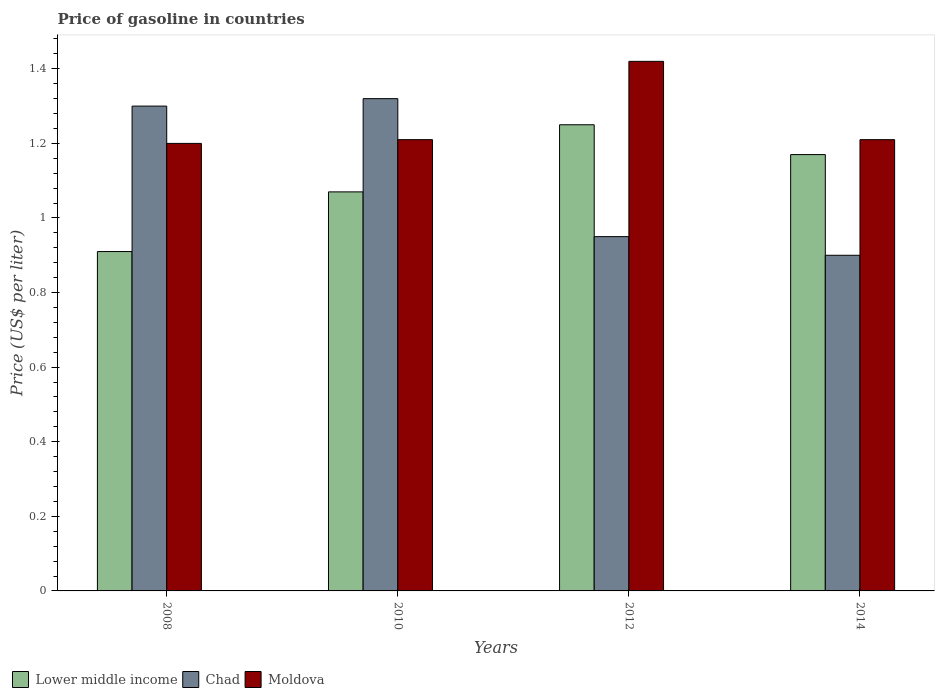How many groups of bars are there?
Provide a succinct answer. 4. How many bars are there on the 1st tick from the right?
Ensure brevity in your answer.  3. What is the price of gasoline in Chad in 2010?
Make the answer very short. 1.32. Across all years, what is the maximum price of gasoline in Lower middle income?
Your answer should be very brief. 1.25. Across all years, what is the minimum price of gasoline in Lower middle income?
Give a very brief answer. 0.91. What is the total price of gasoline in Lower middle income in the graph?
Keep it short and to the point. 4.4. What is the difference between the price of gasoline in Chad in 2010 and that in 2012?
Your answer should be compact. 0.37. What is the difference between the price of gasoline in Lower middle income in 2008 and the price of gasoline in Moldova in 2012?
Your answer should be compact. -0.51. What is the average price of gasoline in Lower middle income per year?
Give a very brief answer. 1.1. In the year 2008, what is the difference between the price of gasoline in Moldova and price of gasoline in Lower middle income?
Your answer should be compact. 0.29. In how many years, is the price of gasoline in Moldova greater than 0.12 US$?
Offer a very short reply. 4. What is the ratio of the price of gasoline in Moldova in 2008 to that in 2010?
Your response must be concise. 0.99. What is the difference between the highest and the second highest price of gasoline in Moldova?
Offer a terse response. 0.21. What is the difference between the highest and the lowest price of gasoline in Lower middle income?
Your answer should be compact. 0.34. In how many years, is the price of gasoline in Chad greater than the average price of gasoline in Chad taken over all years?
Make the answer very short. 2. Is the sum of the price of gasoline in Lower middle income in 2010 and 2014 greater than the maximum price of gasoline in Moldova across all years?
Ensure brevity in your answer.  Yes. What does the 1st bar from the left in 2014 represents?
Make the answer very short. Lower middle income. What does the 1st bar from the right in 2010 represents?
Your response must be concise. Moldova. How many bars are there?
Your response must be concise. 12. Are all the bars in the graph horizontal?
Give a very brief answer. No. How many years are there in the graph?
Keep it short and to the point. 4. What is the difference between two consecutive major ticks on the Y-axis?
Make the answer very short. 0.2. Does the graph contain grids?
Offer a very short reply. No. What is the title of the graph?
Provide a short and direct response. Price of gasoline in countries. What is the label or title of the X-axis?
Make the answer very short. Years. What is the label or title of the Y-axis?
Your answer should be very brief. Price (US$ per liter). What is the Price (US$ per liter) in Lower middle income in 2008?
Provide a short and direct response. 0.91. What is the Price (US$ per liter) in Moldova in 2008?
Your answer should be compact. 1.2. What is the Price (US$ per liter) of Lower middle income in 2010?
Ensure brevity in your answer.  1.07. What is the Price (US$ per liter) in Chad in 2010?
Your answer should be compact. 1.32. What is the Price (US$ per liter) of Moldova in 2010?
Give a very brief answer. 1.21. What is the Price (US$ per liter) in Lower middle income in 2012?
Provide a succinct answer. 1.25. What is the Price (US$ per liter) in Moldova in 2012?
Your response must be concise. 1.42. What is the Price (US$ per liter) in Lower middle income in 2014?
Make the answer very short. 1.17. What is the Price (US$ per liter) in Moldova in 2014?
Your answer should be very brief. 1.21. Across all years, what is the maximum Price (US$ per liter) of Lower middle income?
Your answer should be compact. 1.25. Across all years, what is the maximum Price (US$ per liter) of Chad?
Your response must be concise. 1.32. Across all years, what is the maximum Price (US$ per liter) of Moldova?
Ensure brevity in your answer.  1.42. Across all years, what is the minimum Price (US$ per liter) in Lower middle income?
Make the answer very short. 0.91. Across all years, what is the minimum Price (US$ per liter) of Moldova?
Your answer should be compact. 1.2. What is the total Price (US$ per liter) of Lower middle income in the graph?
Provide a short and direct response. 4.4. What is the total Price (US$ per liter) of Chad in the graph?
Provide a succinct answer. 4.47. What is the total Price (US$ per liter) in Moldova in the graph?
Keep it short and to the point. 5.04. What is the difference between the Price (US$ per liter) of Lower middle income in 2008 and that in 2010?
Your answer should be compact. -0.16. What is the difference between the Price (US$ per liter) in Chad in 2008 and that in 2010?
Provide a succinct answer. -0.02. What is the difference between the Price (US$ per liter) of Moldova in 2008 and that in 2010?
Ensure brevity in your answer.  -0.01. What is the difference between the Price (US$ per liter) in Lower middle income in 2008 and that in 2012?
Keep it short and to the point. -0.34. What is the difference between the Price (US$ per liter) of Moldova in 2008 and that in 2012?
Make the answer very short. -0.22. What is the difference between the Price (US$ per liter) of Lower middle income in 2008 and that in 2014?
Make the answer very short. -0.26. What is the difference between the Price (US$ per liter) of Moldova in 2008 and that in 2014?
Your answer should be compact. -0.01. What is the difference between the Price (US$ per liter) in Lower middle income in 2010 and that in 2012?
Provide a short and direct response. -0.18. What is the difference between the Price (US$ per liter) of Chad in 2010 and that in 2012?
Offer a terse response. 0.37. What is the difference between the Price (US$ per liter) of Moldova in 2010 and that in 2012?
Your response must be concise. -0.21. What is the difference between the Price (US$ per liter) of Lower middle income in 2010 and that in 2014?
Ensure brevity in your answer.  -0.1. What is the difference between the Price (US$ per liter) in Chad in 2010 and that in 2014?
Make the answer very short. 0.42. What is the difference between the Price (US$ per liter) in Moldova in 2012 and that in 2014?
Ensure brevity in your answer.  0.21. What is the difference between the Price (US$ per liter) of Lower middle income in 2008 and the Price (US$ per liter) of Chad in 2010?
Your answer should be compact. -0.41. What is the difference between the Price (US$ per liter) in Lower middle income in 2008 and the Price (US$ per liter) in Moldova in 2010?
Your answer should be very brief. -0.3. What is the difference between the Price (US$ per liter) of Chad in 2008 and the Price (US$ per liter) of Moldova in 2010?
Provide a short and direct response. 0.09. What is the difference between the Price (US$ per liter) of Lower middle income in 2008 and the Price (US$ per liter) of Chad in 2012?
Ensure brevity in your answer.  -0.04. What is the difference between the Price (US$ per liter) of Lower middle income in 2008 and the Price (US$ per liter) of Moldova in 2012?
Your response must be concise. -0.51. What is the difference between the Price (US$ per liter) of Chad in 2008 and the Price (US$ per liter) of Moldova in 2012?
Make the answer very short. -0.12. What is the difference between the Price (US$ per liter) of Lower middle income in 2008 and the Price (US$ per liter) of Moldova in 2014?
Provide a succinct answer. -0.3. What is the difference between the Price (US$ per liter) of Chad in 2008 and the Price (US$ per liter) of Moldova in 2014?
Your response must be concise. 0.09. What is the difference between the Price (US$ per liter) of Lower middle income in 2010 and the Price (US$ per liter) of Chad in 2012?
Offer a terse response. 0.12. What is the difference between the Price (US$ per liter) in Lower middle income in 2010 and the Price (US$ per liter) in Moldova in 2012?
Ensure brevity in your answer.  -0.35. What is the difference between the Price (US$ per liter) of Lower middle income in 2010 and the Price (US$ per liter) of Chad in 2014?
Ensure brevity in your answer.  0.17. What is the difference between the Price (US$ per liter) of Lower middle income in 2010 and the Price (US$ per liter) of Moldova in 2014?
Provide a short and direct response. -0.14. What is the difference between the Price (US$ per liter) of Chad in 2010 and the Price (US$ per liter) of Moldova in 2014?
Your response must be concise. 0.11. What is the difference between the Price (US$ per liter) of Lower middle income in 2012 and the Price (US$ per liter) of Chad in 2014?
Keep it short and to the point. 0.35. What is the difference between the Price (US$ per liter) in Chad in 2012 and the Price (US$ per liter) in Moldova in 2014?
Ensure brevity in your answer.  -0.26. What is the average Price (US$ per liter) of Lower middle income per year?
Your answer should be compact. 1.1. What is the average Price (US$ per liter) of Chad per year?
Your answer should be very brief. 1.12. What is the average Price (US$ per liter) in Moldova per year?
Your answer should be compact. 1.26. In the year 2008, what is the difference between the Price (US$ per liter) in Lower middle income and Price (US$ per liter) in Chad?
Provide a succinct answer. -0.39. In the year 2008, what is the difference between the Price (US$ per liter) of Lower middle income and Price (US$ per liter) of Moldova?
Offer a very short reply. -0.29. In the year 2010, what is the difference between the Price (US$ per liter) in Lower middle income and Price (US$ per liter) in Moldova?
Offer a very short reply. -0.14. In the year 2010, what is the difference between the Price (US$ per liter) of Chad and Price (US$ per liter) of Moldova?
Ensure brevity in your answer.  0.11. In the year 2012, what is the difference between the Price (US$ per liter) in Lower middle income and Price (US$ per liter) in Chad?
Provide a short and direct response. 0.3. In the year 2012, what is the difference between the Price (US$ per liter) of Lower middle income and Price (US$ per liter) of Moldova?
Your response must be concise. -0.17. In the year 2012, what is the difference between the Price (US$ per liter) of Chad and Price (US$ per liter) of Moldova?
Give a very brief answer. -0.47. In the year 2014, what is the difference between the Price (US$ per liter) in Lower middle income and Price (US$ per liter) in Chad?
Make the answer very short. 0.27. In the year 2014, what is the difference between the Price (US$ per liter) in Lower middle income and Price (US$ per liter) in Moldova?
Provide a succinct answer. -0.04. In the year 2014, what is the difference between the Price (US$ per liter) in Chad and Price (US$ per liter) in Moldova?
Offer a very short reply. -0.31. What is the ratio of the Price (US$ per liter) in Lower middle income in 2008 to that in 2010?
Your answer should be very brief. 0.85. What is the ratio of the Price (US$ per liter) in Moldova in 2008 to that in 2010?
Give a very brief answer. 0.99. What is the ratio of the Price (US$ per liter) in Lower middle income in 2008 to that in 2012?
Ensure brevity in your answer.  0.73. What is the ratio of the Price (US$ per liter) of Chad in 2008 to that in 2012?
Offer a terse response. 1.37. What is the ratio of the Price (US$ per liter) of Moldova in 2008 to that in 2012?
Provide a succinct answer. 0.85. What is the ratio of the Price (US$ per liter) of Chad in 2008 to that in 2014?
Offer a terse response. 1.44. What is the ratio of the Price (US$ per liter) in Lower middle income in 2010 to that in 2012?
Give a very brief answer. 0.86. What is the ratio of the Price (US$ per liter) of Chad in 2010 to that in 2012?
Give a very brief answer. 1.39. What is the ratio of the Price (US$ per liter) of Moldova in 2010 to that in 2012?
Give a very brief answer. 0.85. What is the ratio of the Price (US$ per liter) in Lower middle income in 2010 to that in 2014?
Your answer should be very brief. 0.91. What is the ratio of the Price (US$ per liter) in Chad in 2010 to that in 2014?
Your answer should be compact. 1.47. What is the ratio of the Price (US$ per liter) in Lower middle income in 2012 to that in 2014?
Give a very brief answer. 1.07. What is the ratio of the Price (US$ per liter) in Chad in 2012 to that in 2014?
Provide a succinct answer. 1.06. What is the ratio of the Price (US$ per liter) of Moldova in 2012 to that in 2014?
Your response must be concise. 1.17. What is the difference between the highest and the second highest Price (US$ per liter) of Moldova?
Provide a succinct answer. 0.21. What is the difference between the highest and the lowest Price (US$ per liter) in Lower middle income?
Provide a short and direct response. 0.34. What is the difference between the highest and the lowest Price (US$ per liter) in Chad?
Offer a very short reply. 0.42. What is the difference between the highest and the lowest Price (US$ per liter) in Moldova?
Give a very brief answer. 0.22. 